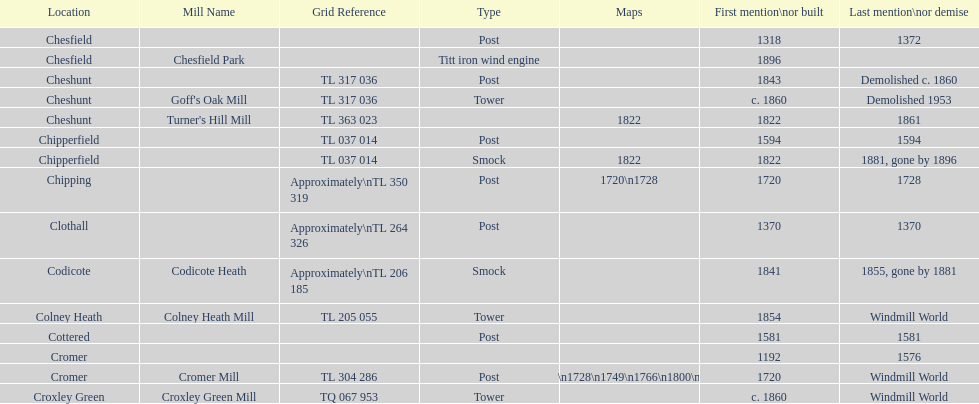How man "c" windmills have there been? 15. I'm looking to parse the entire table for insights. Could you assist me with that? {'header': ['Location', 'Mill Name', 'Grid Reference', 'Type', 'Maps', 'First mention\\nor built', 'Last mention\\nor demise'], 'rows': [['Chesfield', '', '', 'Post', '', '1318', '1372'], ['Chesfield', 'Chesfield Park', '', 'Titt iron wind engine', '', '1896', ''], ['Cheshunt', '', 'TL 317 036', 'Post', '', '1843', 'Demolished c. 1860'], ['Cheshunt', "Goff's Oak Mill", 'TL 317 036', 'Tower', '', 'c. 1860', 'Demolished 1953'], ['Cheshunt', "Turner's Hill Mill", 'TL 363 023', '', '1822', '1822', '1861'], ['Chipperfield', '', 'TL 037 014', 'Post', '', '1594', '1594'], ['Chipperfield', '', 'TL 037 014', 'Smock', '1822', '1822', '1881, gone by 1896'], ['Chipping', '', 'Approximately\\nTL 350 319', 'Post', '1720\\n1728', '1720', '1728'], ['Clothall', '', 'Approximately\\nTL 264 326', 'Post', '', '1370', '1370'], ['Codicote', 'Codicote Heath', 'Approximately\\nTL 206 185', 'Smock', '', '1841', '1855, gone by 1881'], ['Colney Heath', 'Colney Heath Mill', 'TL 205 055', 'Tower', '', '1854', 'Windmill World'], ['Cottered', '', '', 'Post', '', '1581', '1581'], ['Cromer', '', '', '', '', '1192', '1576'], ['Cromer', 'Cromer Mill', 'TL 304 286', 'Post', '1720\\n1728\\n1749\\n1766\\n1800\\n1822', '1720', 'Windmill World'], ['Croxley Green', 'Croxley Green Mill', 'TQ 067 953', 'Tower', '', 'c. 1860', 'Windmill World']]} 